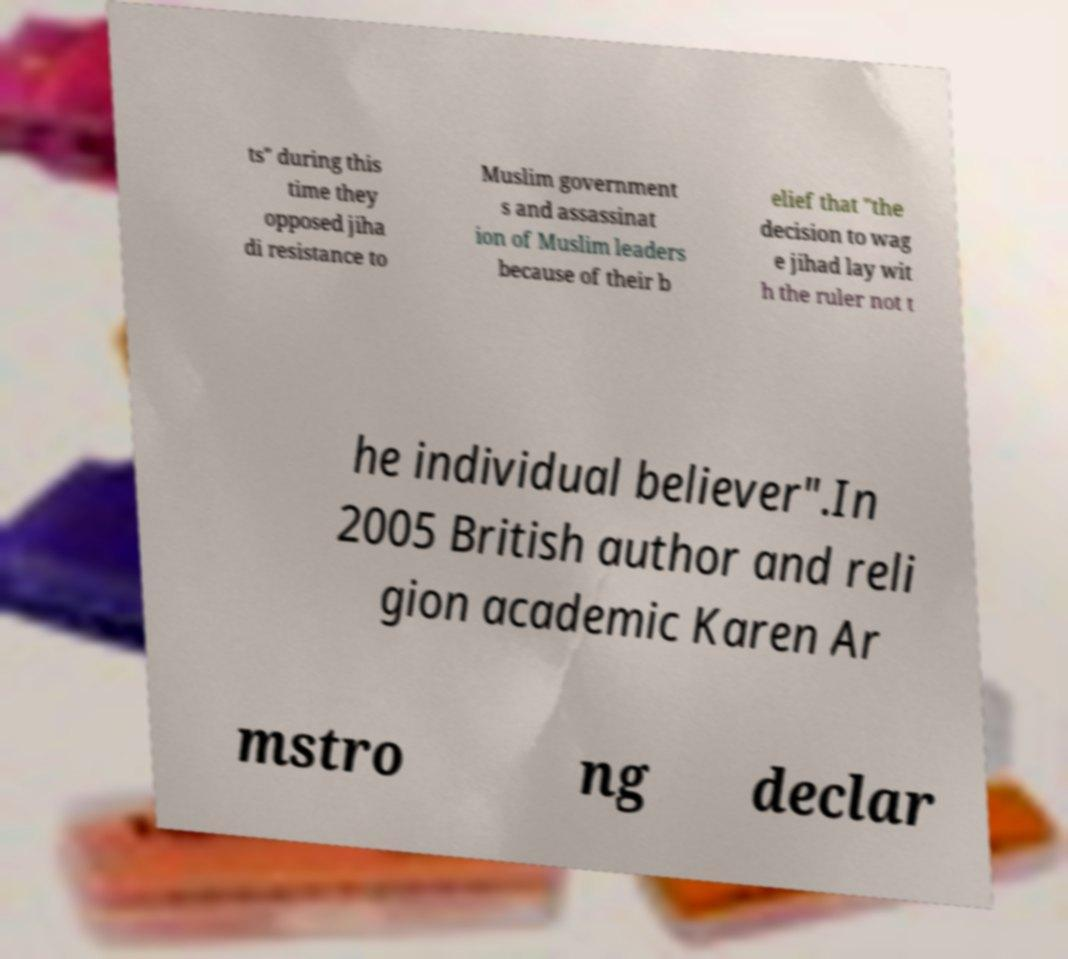I need the written content from this picture converted into text. Can you do that? ts" during this time they opposed jiha di resistance to Muslim government s and assassinat ion of Muslim leaders because of their b elief that "the decision to wag e jihad lay wit h the ruler not t he individual believer".In 2005 British author and reli gion academic Karen Ar mstro ng declar 